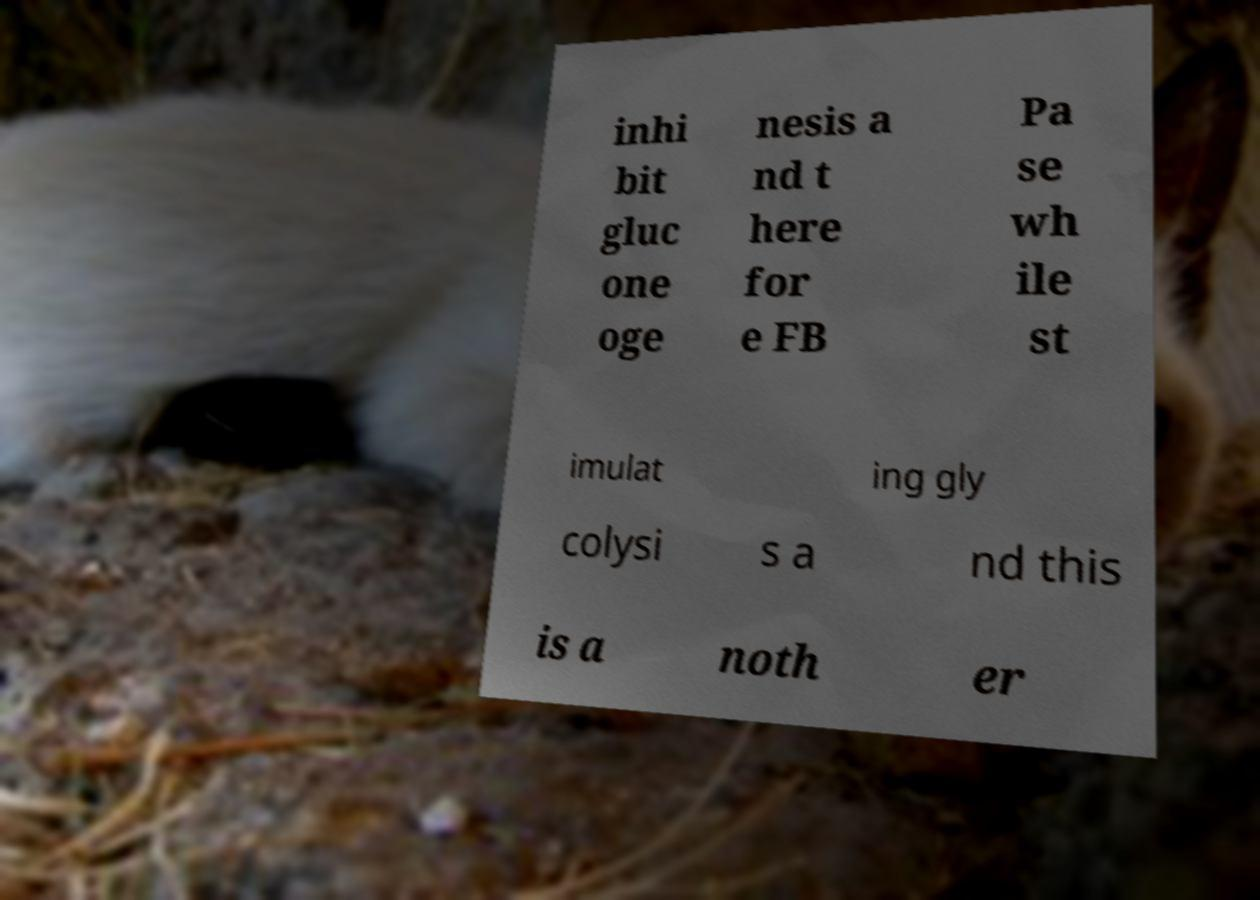There's text embedded in this image that I need extracted. Can you transcribe it verbatim? inhi bit gluc one oge nesis a nd t here for e FB Pa se wh ile st imulat ing gly colysi s a nd this is a noth er 